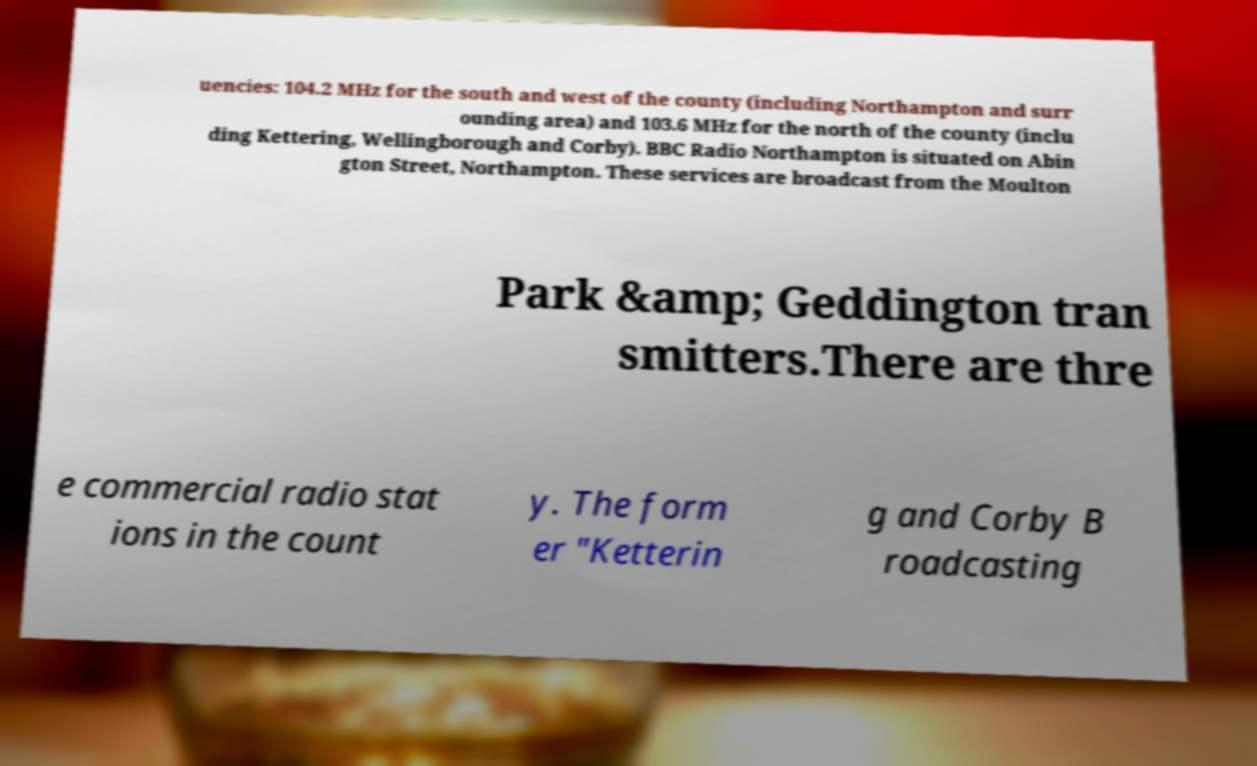What messages or text are displayed in this image? I need them in a readable, typed format. uencies: 104.2 MHz for the south and west of the county (including Northampton and surr ounding area) and 103.6 MHz for the north of the county (inclu ding Kettering, Wellingborough and Corby). BBC Radio Northampton is situated on Abin gton Street, Northampton. These services are broadcast from the Moulton Park &amp; Geddington tran smitters.There are thre e commercial radio stat ions in the count y. The form er "Ketterin g and Corby B roadcasting 